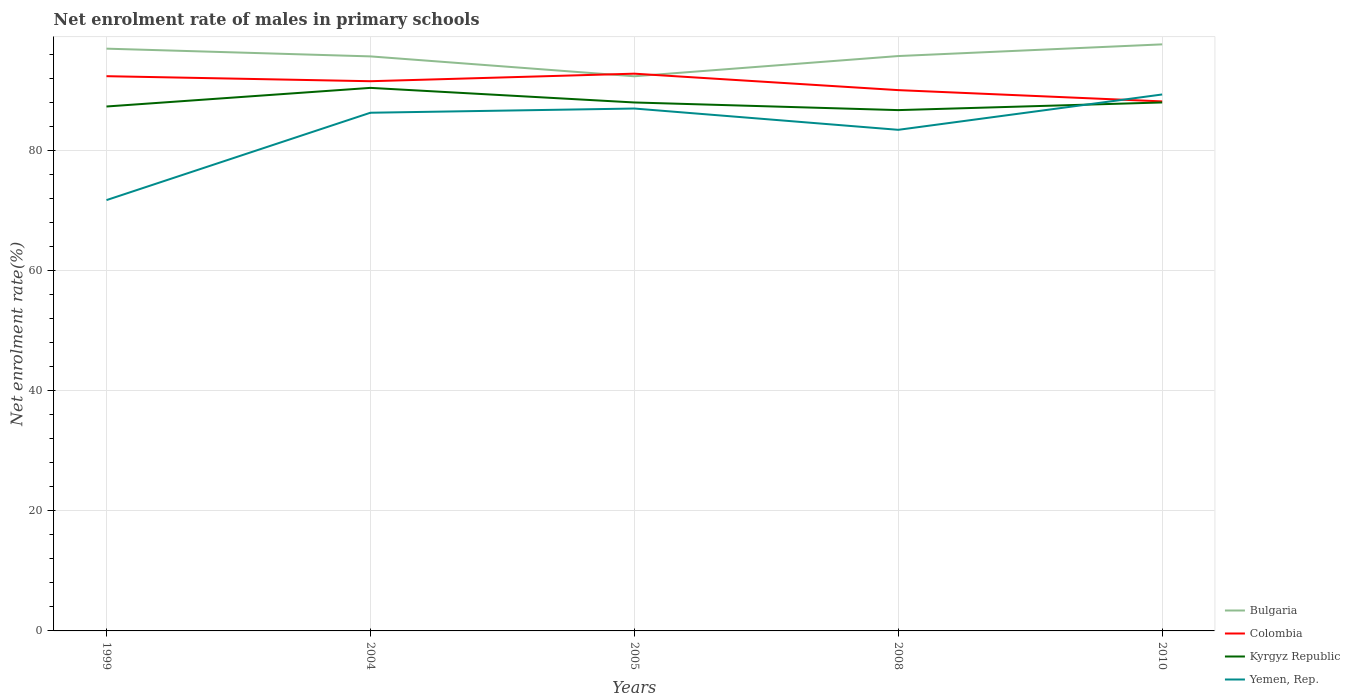How many different coloured lines are there?
Offer a terse response. 4. Across all years, what is the maximum net enrolment rate of males in primary schools in Yemen, Rep.?
Provide a succinct answer. 71.79. In which year was the net enrolment rate of males in primary schools in Colombia maximum?
Your answer should be very brief. 2010. What is the total net enrolment rate of males in primary schools in Yemen, Rep. in the graph?
Give a very brief answer. 2.85. What is the difference between the highest and the second highest net enrolment rate of males in primary schools in Colombia?
Ensure brevity in your answer.  4.62. What is the difference between the highest and the lowest net enrolment rate of males in primary schools in Yemen, Rep.?
Provide a succinct answer. 3. Is the net enrolment rate of males in primary schools in Bulgaria strictly greater than the net enrolment rate of males in primary schools in Yemen, Rep. over the years?
Keep it short and to the point. No. What is the difference between two consecutive major ticks on the Y-axis?
Offer a terse response. 20. Are the values on the major ticks of Y-axis written in scientific E-notation?
Your answer should be very brief. No. Does the graph contain any zero values?
Provide a succinct answer. No. Does the graph contain grids?
Give a very brief answer. Yes. Where does the legend appear in the graph?
Provide a succinct answer. Bottom right. How are the legend labels stacked?
Give a very brief answer. Vertical. What is the title of the graph?
Give a very brief answer. Net enrolment rate of males in primary schools. What is the label or title of the Y-axis?
Ensure brevity in your answer.  Net enrolment rate(%). What is the Net enrolment rate(%) in Bulgaria in 1999?
Offer a very short reply. 97.03. What is the Net enrolment rate(%) of Colombia in 1999?
Your answer should be compact. 92.44. What is the Net enrolment rate(%) of Kyrgyz Republic in 1999?
Keep it short and to the point. 87.39. What is the Net enrolment rate(%) of Yemen, Rep. in 1999?
Your answer should be compact. 71.79. What is the Net enrolment rate(%) of Bulgaria in 2004?
Make the answer very short. 95.74. What is the Net enrolment rate(%) of Colombia in 2004?
Make the answer very short. 91.61. What is the Net enrolment rate(%) in Kyrgyz Republic in 2004?
Your response must be concise. 90.5. What is the Net enrolment rate(%) in Yemen, Rep. in 2004?
Ensure brevity in your answer.  86.35. What is the Net enrolment rate(%) in Bulgaria in 2005?
Provide a short and direct response. 92.43. What is the Net enrolment rate(%) of Colombia in 2005?
Offer a very short reply. 92.86. What is the Net enrolment rate(%) of Kyrgyz Republic in 2005?
Ensure brevity in your answer.  88.06. What is the Net enrolment rate(%) of Yemen, Rep. in 2005?
Offer a very short reply. 87.05. What is the Net enrolment rate(%) of Bulgaria in 2008?
Your answer should be compact. 95.8. What is the Net enrolment rate(%) of Colombia in 2008?
Your answer should be very brief. 90.12. What is the Net enrolment rate(%) in Kyrgyz Republic in 2008?
Your answer should be compact. 86.79. What is the Net enrolment rate(%) in Yemen, Rep. in 2008?
Ensure brevity in your answer.  83.51. What is the Net enrolment rate(%) of Bulgaria in 2010?
Keep it short and to the point. 97.75. What is the Net enrolment rate(%) of Colombia in 2010?
Your answer should be compact. 88.24. What is the Net enrolment rate(%) of Kyrgyz Republic in 2010?
Ensure brevity in your answer.  88.07. What is the Net enrolment rate(%) of Yemen, Rep. in 2010?
Your answer should be compact. 89.39. Across all years, what is the maximum Net enrolment rate(%) in Bulgaria?
Your answer should be compact. 97.75. Across all years, what is the maximum Net enrolment rate(%) of Colombia?
Ensure brevity in your answer.  92.86. Across all years, what is the maximum Net enrolment rate(%) of Kyrgyz Republic?
Provide a succinct answer. 90.5. Across all years, what is the maximum Net enrolment rate(%) in Yemen, Rep.?
Ensure brevity in your answer.  89.39. Across all years, what is the minimum Net enrolment rate(%) in Bulgaria?
Give a very brief answer. 92.43. Across all years, what is the minimum Net enrolment rate(%) in Colombia?
Your answer should be very brief. 88.24. Across all years, what is the minimum Net enrolment rate(%) in Kyrgyz Republic?
Your answer should be compact. 86.79. Across all years, what is the minimum Net enrolment rate(%) in Yemen, Rep.?
Offer a very short reply. 71.79. What is the total Net enrolment rate(%) in Bulgaria in the graph?
Give a very brief answer. 478.75. What is the total Net enrolment rate(%) in Colombia in the graph?
Your answer should be compact. 455.27. What is the total Net enrolment rate(%) in Kyrgyz Republic in the graph?
Provide a short and direct response. 440.81. What is the total Net enrolment rate(%) of Yemen, Rep. in the graph?
Ensure brevity in your answer.  418.1. What is the difference between the Net enrolment rate(%) in Bulgaria in 1999 and that in 2004?
Provide a succinct answer. 1.29. What is the difference between the Net enrolment rate(%) in Colombia in 1999 and that in 2004?
Make the answer very short. 0.84. What is the difference between the Net enrolment rate(%) in Kyrgyz Republic in 1999 and that in 2004?
Offer a very short reply. -3.1. What is the difference between the Net enrolment rate(%) of Yemen, Rep. in 1999 and that in 2004?
Offer a terse response. -14.56. What is the difference between the Net enrolment rate(%) in Bulgaria in 1999 and that in 2005?
Your response must be concise. 4.6. What is the difference between the Net enrolment rate(%) in Colombia in 1999 and that in 2005?
Your response must be concise. -0.42. What is the difference between the Net enrolment rate(%) of Kyrgyz Republic in 1999 and that in 2005?
Provide a short and direct response. -0.67. What is the difference between the Net enrolment rate(%) in Yemen, Rep. in 1999 and that in 2005?
Your response must be concise. -15.26. What is the difference between the Net enrolment rate(%) in Bulgaria in 1999 and that in 2008?
Your answer should be very brief. 1.23. What is the difference between the Net enrolment rate(%) of Colombia in 1999 and that in 2008?
Offer a terse response. 2.32. What is the difference between the Net enrolment rate(%) of Kyrgyz Republic in 1999 and that in 2008?
Provide a short and direct response. 0.6. What is the difference between the Net enrolment rate(%) in Yemen, Rep. in 1999 and that in 2008?
Your answer should be compact. -11.71. What is the difference between the Net enrolment rate(%) in Bulgaria in 1999 and that in 2010?
Your response must be concise. -0.71. What is the difference between the Net enrolment rate(%) in Colombia in 1999 and that in 2010?
Your answer should be compact. 4.2. What is the difference between the Net enrolment rate(%) in Kyrgyz Republic in 1999 and that in 2010?
Give a very brief answer. -0.67. What is the difference between the Net enrolment rate(%) of Yemen, Rep. in 1999 and that in 2010?
Your answer should be compact. -17.6. What is the difference between the Net enrolment rate(%) of Bulgaria in 2004 and that in 2005?
Ensure brevity in your answer.  3.31. What is the difference between the Net enrolment rate(%) of Colombia in 2004 and that in 2005?
Your response must be concise. -1.26. What is the difference between the Net enrolment rate(%) of Kyrgyz Republic in 2004 and that in 2005?
Keep it short and to the point. 2.43. What is the difference between the Net enrolment rate(%) in Yemen, Rep. in 2004 and that in 2005?
Give a very brief answer. -0.7. What is the difference between the Net enrolment rate(%) in Bulgaria in 2004 and that in 2008?
Ensure brevity in your answer.  -0.06. What is the difference between the Net enrolment rate(%) in Colombia in 2004 and that in 2008?
Your answer should be compact. 1.49. What is the difference between the Net enrolment rate(%) of Kyrgyz Republic in 2004 and that in 2008?
Your answer should be very brief. 3.71. What is the difference between the Net enrolment rate(%) of Yemen, Rep. in 2004 and that in 2008?
Your response must be concise. 2.85. What is the difference between the Net enrolment rate(%) in Bulgaria in 2004 and that in 2010?
Keep it short and to the point. -2. What is the difference between the Net enrolment rate(%) of Colombia in 2004 and that in 2010?
Provide a succinct answer. 3.37. What is the difference between the Net enrolment rate(%) of Kyrgyz Republic in 2004 and that in 2010?
Your response must be concise. 2.43. What is the difference between the Net enrolment rate(%) of Yemen, Rep. in 2004 and that in 2010?
Give a very brief answer. -3.04. What is the difference between the Net enrolment rate(%) in Bulgaria in 2005 and that in 2008?
Your answer should be very brief. -3.37. What is the difference between the Net enrolment rate(%) in Colombia in 2005 and that in 2008?
Offer a terse response. 2.74. What is the difference between the Net enrolment rate(%) of Kyrgyz Republic in 2005 and that in 2008?
Provide a succinct answer. 1.27. What is the difference between the Net enrolment rate(%) of Yemen, Rep. in 2005 and that in 2008?
Keep it short and to the point. 3.55. What is the difference between the Net enrolment rate(%) in Bulgaria in 2005 and that in 2010?
Offer a very short reply. -5.32. What is the difference between the Net enrolment rate(%) of Colombia in 2005 and that in 2010?
Your answer should be compact. 4.62. What is the difference between the Net enrolment rate(%) in Kyrgyz Republic in 2005 and that in 2010?
Your answer should be very brief. -0. What is the difference between the Net enrolment rate(%) of Yemen, Rep. in 2005 and that in 2010?
Give a very brief answer. -2.34. What is the difference between the Net enrolment rate(%) of Bulgaria in 2008 and that in 2010?
Your answer should be compact. -1.95. What is the difference between the Net enrolment rate(%) in Colombia in 2008 and that in 2010?
Provide a short and direct response. 1.88. What is the difference between the Net enrolment rate(%) of Kyrgyz Republic in 2008 and that in 2010?
Your answer should be compact. -1.28. What is the difference between the Net enrolment rate(%) of Yemen, Rep. in 2008 and that in 2010?
Give a very brief answer. -5.89. What is the difference between the Net enrolment rate(%) in Bulgaria in 1999 and the Net enrolment rate(%) in Colombia in 2004?
Keep it short and to the point. 5.43. What is the difference between the Net enrolment rate(%) of Bulgaria in 1999 and the Net enrolment rate(%) of Kyrgyz Republic in 2004?
Keep it short and to the point. 6.54. What is the difference between the Net enrolment rate(%) in Bulgaria in 1999 and the Net enrolment rate(%) in Yemen, Rep. in 2004?
Offer a very short reply. 10.68. What is the difference between the Net enrolment rate(%) of Colombia in 1999 and the Net enrolment rate(%) of Kyrgyz Republic in 2004?
Make the answer very short. 1.95. What is the difference between the Net enrolment rate(%) in Colombia in 1999 and the Net enrolment rate(%) in Yemen, Rep. in 2004?
Ensure brevity in your answer.  6.09. What is the difference between the Net enrolment rate(%) in Kyrgyz Republic in 1999 and the Net enrolment rate(%) in Yemen, Rep. in 2004?
Ensure brevity in your answer.  1.04. What is the difference between the Net enrolment rate(%) in Bulgaria in 1999 and the Net enrolment rate(%) in Colombia in 2005?
Offer a very short reply. 4.17. What is the difference between the Net enrolment rate(%) of Bulgaria in 1999 and the Net enrolment rate(%) of Kyrgyz Republic in 2005?
Your response must be concise. 8.97. What is the difference between the Net enrolment rate(%) in Bulgaria in 1999 and the Net enrolment rate(%) in Yemen, Rep. in 2005?
Your answer should be very brief. 9.98. What is the difference between the Net enrolment rate(%) in Colombia in 1999 and the Net enrolment rate(%) in Kyrgyz Republic in 2005?
Give a very brief answer. 4.38. What is the difference between the Net enrolment rate(%) in Colombia in 1999 and the Net enrolment rate(%) in Yemen, Rep. in 2005?
Give a very brief answer. 5.39. What is the difference between the Net enrolment rate(%) of Kyrgyz Republic in 1999 and the Net enrolment rate(%) of Yemen, Rep. in 2005?
Offer a terse response. 0.34. What is the difference between the Net enrolment rate(%) in Bulgaria in 1999 and the Net enrolment rate(%) in Colombia in 2008?
Offer a very short reply. 6.91. What is the difference between the Net enrolment rate(%) of Bulgaria in 1999 and the Net enrolment rate(%) of Kyrgyz Republic in 2008?
Give a very brief answer. 10.24. What is the difference between the Net enrolment rate(%) in Bulgaria in 1999 and the Net enrolment rate(%) in Yemen, Rep. in 2008?
Offer a very short reply. 13.53. What is the difference between the Net enrolment rate(%) in Colombia in 1999 and the Net enrolment rate(%) in Kyrgyz Republic in 2008?
Provide a short and direct response. 5.65. What is the difference between the Net enrolment rate(%) of Colombia in 1999 and the Net enrolment rate(%) of Yemen, Rep. in 2008?
Your answer should be very brief. 8.94. What is the difference between the Net enrolment rate(%) of Kyrgyz Republic in 1999 and the Net enrolment rate(%) of Yemen, Rep. in 2008?
Provide a succinct answer. 3.89. What is the difference between the Net enrolment rate(%) of Bulgaria in 1999 and the Net enrolment rate(%) of Colombia in 2010?
Give a very brief answer. 8.79. What is the difference between the Net enrolment rate(%) of Bulgaria in 1999 and the Net enrolment rate(%) of Kyrgyz Republic in 2010?
Keep it short and to the point. 8.97. What is the difference between the Net enrolment rate(%) of Bulgaria in 1999 and the Net enrolment rate(%) of Yemen, Rep. in 2010?
Provide a short and direct response. 7.64. What is the difference between the Net enrolment rate(%) in Colombia in 1999 and the Net enrolment rate(%) in Kyrgyz Republic in 2010?
Offer a very short reply. 4.38. What is the difference between the Net enrolment rate(%) of Colombia in 1999 and the Net enrolment rate(%) of Yemen, Rep. in 2010?
Your answer should be compact. 3.05. What is the difference between the Net enrolment rate(%) in Kyrgyz Republic in 1999 and the Net enrolment rate(%) in Yemen, Rep. in 2010?
Your answer should be very brief. -2. What is the difference between the Net enrolment rate(%) of Bulgaria in 2004 and the Net enrolment rate(%) of Colombia in 2005?
Make the answer very short. 2.88. What is the difference between the Net enrolment rate(%) of Bulgaria in 2004 and the Net enrolment rate(%) of Kyrgyz Republic in 2005?
Offer a very short reply. 7.68. What is the difference between the Net enrolment rate(%) of Bulgaria in 2004 and the Net enrolment rate(%) of Yemen, Rep. in 2005?
Provide a succinct answer. 8.69. What is the difference between the Net enrolment rate(%) in Colombia in 2004 and the Net enrolment rate(%) in Kyrgyz Republic in 2005?
Provide a succinct answer. 3.54. What is the difference between the Net enrolment rate(%) of Colombia in 2004 and the Net enrolment rate(%) of Yemen, Rep. in 2005?
Provide a short and direct response. 4.55. What is the difference between the Net enrolment rate(%) of Kyrgyz Republic in 2004 and the Net enrolment rate(%) of Yemen, Rep. in 2005?
Give a very brief answer. 3.44. What is the difference between the Net enrolment rate(%) of Bulgaria in 2004 and the Net enrolment rate(%) of Colombia in 2008?
Your response must be concise. 5.62. What is the difference between the Net enrolment rate(%) of Bulgaria in 2004 and the Net enrolment rate(%) of Kyrgyz Republic in 2008?
Offer a terse response. 8.95. What is the difference between the Net enrolment rate(%) of Bulgaria in 2004 and the Net enrolment rate(%) of Yemen, Rep. in 2008?
Offer a terse response. 12.24. What is the difference between the Net enrolment rate(%) of Colombia in 2004 and the Net enrolment rate(%) of Kyrgyz Republic in 2008?
Provide a succinct answer. 4.82. What is the difference between the Net enrolment rate(%) in Colombia in 2004 and the Net enrolment rate(%) in Yemen, Rep. in 2008?
Your answer should be very brief. 8.1. What is the difference between the Net enrolment rate(%) of Kyrgyz Republic in 2004 and the Net enrolment rate(%) of Yemen, Rep. in 2008?
Give a very brief answer. 6.99. What is the difference between the Net enrolment rate(%) in Bulgaria in 2004 and the Net enrolment rate(%) in Colombia in 2010?
Give a very brief answer. 7.5. What is the difference between the Net enrolment rate(%) in Bulgaria in 2004 and the Net enrolment rate(%) in Kyrgyz Republic in 2010?
Ensure brevity in your answer.  7.68. What is the difference between the Net enrolment rate(%) in Bulgaria in 2004 and the Net enrolment rate(%) in Yemen, Rep. in 2010?
Provide a short and direct response. 6.35. What is the difference between the Net enrolment rate(%) in Colombia in 2004 and the Net enrolment rate(%) in Kyrgyz Republic in 2010?
Make the answer very short. 3.54. What is the difference between the Net enrolment rate(%) in Colombia in 2004 and the Net enrolment rate(%) in Yemen, Rep. in 2010?
Keep it short and to the point. 2.21. What is the difference between the Net enrolment rate(%) of Kyrgyz Republic in 2004 and the Net enrolment rate(%) of Yemen, Rep. in 2010?
Your response must be concise. 1.1. What is the difference between the Net enrolment rate(%) in Bulgaria in 2005 and the Net enrolment rate(%) in Colombia in 2008?
Offer a very short reply. 2.31. What is the difference between the Net enrolment rate(%) in Bulgaria in 2005 and the Net enrolment rate(%) in Kyrgyz Republic in 2008?
Ensure brevity in your answer.  5.64. What is the difference between the Net enrolment rate(%) in Bulgaria in 2005 and the Net enrolment rate(%) in Yemen, Rep. in 2008?
Make the answer very short. 8.92. What is the difference between the Net enrolment rate(%) of Colombia in 2005 and the Net enrolment rate(%) of Kyrgyz Republic in 2008?
Your response must be concise. 6.07. What is the difference between the Net enrolment rate(%) of Colombia in 2005 and the Net enrolment rate(%) of Yemen, Rep. in 2008?
Your answer should be very brief. 9.36. What is the difference between the Net enrolment rate(%) of Kyrgyz Republic in 2005 and the Net enrolment rate(%) of Yemen, Rep. in 2008?
Offer a very short reply. 4.56. What is the difference between the Net enrolment rate(%) in Bulgaria in 2005 and the Net enrolment rate(%) in Colombia in 2010?
Offer a very short reply. 4.19. What is the difference between the Net enrolment rate(%) of Bulgaria in 2005 and the Net enrolment rate(%) of Kyrgyz Republic in 2010?
Your answer should be compact. 4.36. What is the difference between the Net enrolment rate(%) of Bulgaria in 2005 and the Net enrolment rate(%) of Yemen, Rep. in 2010?
Ensure brevity in your answer.  3.03. What is the difference between the Net enrolment rate(%) of Colombia in 2005 and the Net enrolment rate(%) of Kyrgyz Republic in 2010?
Offer a very short reply. 4.8. What is the difference between the Net enrolment rate(%) of Colombia in 2005 and the Net enrolment rate(%) of Yemen, Rep. in 2010?
Ensure brevity in your answer.  3.47. What is the difference between the Net enrolment rate(%) of Kyrgyz Republic in 2005 and the Net enrolment rate(%) of Yemen, Rep. in 2010?
Your response must be concise. -1.33. What is the difference between the Net enrolment rate(%) of Bulgaria in 2008 and the Net enrolment rate(%) of Colombia in 2010?
Offer a very short reply. 7.56. What is the difference between the Net enrolment rate(%) of Bulgaria in 2008 and the Net enrolment rate(%) of Kyrgyz Republic in 2010?
Offer a very short reply. 7.73. What is the difference between the Net enrolment rate(%) in Bulgaria in 2008 and the Net enrolment rate(%) in Yemen, Rep. in 2010?
Provide a short and direct response. 6.4. What is the difference between the Net enrolment rate(%) of Colombia in 2008 and the Net enrolment rate(%) of Kyrgyz Republic in 2010?
Your response must be concise. 2.05. What is the difference between the Net enrolment rate(%) of Colombia in 2008 and the Net enrolment rate(%) of Yemen, Rep. in 2010?
Your answer should be compact. 0.73. What is the difference between the Net enrolment rate(%) of Kyrgyz Republic in 2008 and the Net enrolment rate(%) of Yemen, Rep. in 2010?
Offer a very short reply. -2.6. What is the average Net enrolment rate(%) of Bulgaria per year?
Offer a very short reply. 95.75. What is the average Net enrolment rate(%) in Colombia per year?
Offer a terse response. 91.05. What is the average Net enrolment rate(%) in Kyrgyz Republic per year?
Give a very brief answer. 88.16. What is the average Net enrolment rate(%) in Yemen, Rep. per year?
Provide a succinct answer. 83.62. In the year 1999, what is the difference between the Net enrolment rate(%) in Bulgaria and Net enrolment rate(%) in Colombia?
Offer a very short reply. 4.59. In the year 1999, what is the difference between the Net enrolment rate(%) in Bulgaria and Net enrolment rate(%) in Kyrgyz Republic?
Provide a succinct answer. 9.64. In the year 1999, what is the difference between the Net enrolment rate(%) in Bulgaria and Net enrolment rate(%) in Yemen, Rep.?
Provide a short and direct response. 25.24. In the year 1999, what is the difference between the Net enrolment rate(%) of Colombia and Net enrolment rate(%) of Kyrgyz Republic?
Your answer should be compact. 5.05. In the year 1999, what is the difference between the Net enrolment rate(%) in Colombia and Net enrolment rate(%) in Yemen, Rep.?
Your answer should be compact. 20.65. In the year 1999, what is the difference between the Net enrolment rate(%) of Kyrgyz Republic and Net enrolment rate(%) of Yemen, Rep.?
Provide a short and direct response. 15.6. In the year 2004, what is the difference between the Net enrolment rate(%) of Bulgaria and Net enrolment rate(%) of Colombia?
Provide a succinct answer. 4.14. In the year 2004, what is the difference between the Net enrolment rate(%) of Bulgaria and Net enrolment rate(%) of Kyrgyz Republic?
Your answer should be compact. 5.25. In the year 2004, what is the difference between the Net enrolment rate(%) in Bulgaria and Net enrolment rate(%) in Yemen, Rep.?
Your response must be concise. 9.39. In the year 2004, what is the difference between the Net enrolment rate(%) in Colombia and Net enrolment rate(%) in Kyrgyz Republic?
Provide a short and direct response. 1.11. In the year 2004, what is the difference between the Net enrolment rate(%) of Colombia and Net enrolment rate(%) of Yemen, Rep.?
Provide a succinct answer. 5.25. In the year 2004, what is the difference between the Net enrolment rate(%) of Kyrgyz Republic and Net enrolment rate(%) of Yemen, Rep.?
Provide a short and direct response. 4.14. In the year 2005, what is the difference between the Net enrolment rate(%) in Bulgaria and Net enrolment rate(%) in Colombia?
Your answer should be very brief. -0.43. In the year 2005, what is the difference between the Net enrolment rate(%) of Bulgaria and Net enrolment rate(%) of Kyrgyz Republic?
Offer a terse response. 4.37. In the year 2005, what is the difference between the Net enrolment rate(%) in Bulgaria and Net enrolment rate(%) in Yemen, Rep.?
Offer a terse response. 5.37. In the year 2005, what is the difference between the Net enrolment rate(%) in Colombia and Net enrolment rate(%) in Kyrgyz Republic?
Your answer should be compact. 4.8. In the year 2005, what is the difference between the Net enrolment rate(%) in Colombia and Net enrolment rate(%) in Yemen, Rep.?
Keep it short and to the point. 5.81. In the year 2005, what is the difference between the Net enrolment rate(%) in Kyrgyz Republic and Net enrolment rate(%) in Yemen, Rep.?
Offer a very short reply. 1.01. In the year 2008, what is the difference between the Net enrolment rate(%) in Bulgaria and Net enrolment rate(%) in Colombia?
Your answer should be compact. 5.68. In the year 2008, what is the difference between the Net enrolment rate(%) in Bulgaria and Net enrolment rate(%) in Kyrgyz Republic?
Provide a succinct answer. 9.01. In the year 2008, what is the difference between the Net enrolment rate(%) of Bulgaria and Net enrolment rate(%) of Yemen, Rep.?
Your response must be concise. 12.29. In the year 2008, what is the difference between the Net enrolment rate(%) in Colombia and Net enrolment rate(%) in Kyrgyz Republic?
Provide a succinct answer. 3.33. In the year 2008, what is the difference between the Net enrolment rate(%) of Colombia and Net enrolment rate(%) of Yemen, Rep.?
Provide a succinct answer. 6.61. In the year 2008, what is the difference between the Net enrolment rate(%) in Kyrgyz Republic and Net enrolment rate(%) in Yemen, Rep.?
Provide a succinct answer. 3.28. In the year 2010, what is the difference between the Net enrolment rate(%) in Bulgaria and Net enrolment rate(%) in Colombia?
Provide a succinct answer. 9.51. In the year 2010, what is the difference between the Net enrolment rate(%) of Bulgaria and Net enrolment rate(%) of Kyrgyz Republic?
Your answer should be compact. 9.68. In the year 2010, what is the difference between the Net enrolment rate(%) in Bulgaria and Net enrolment rate(%) in Yemen, Rep.?
Ensure brevity in your answer.  8.35. In the year 2010, what is the difference between the Net enrolment rate(%) in Colombia and Net enrolment rate(%) in Kyrgyz Republic?
Offer a very short reply. 0.17. In the year 2010, what is the difference between the Net enrolment rate(%) of Colombia and Net enrolment rate(%) of Yemen, Rep.?
Your answer should be compact. -1.15. In the year 2010, what is the difference between the Net enrolment rate(%) in Kyrgyz Republic and Net enrolment rate(%) in Yemen, Rep.?
Keep it short and to the point. -1.33. What is the ratio of the Net enrolment rate(%) of Bulgaria in 1999 to that in 2004?
Offer a terse response. 1.01. What is the ratio of the Net enrolment rate(%) in Colombia in 1999 to that in 2004?
Your answer should be very brief. 1.01. What is the ratio of the Net enrolment rate(%) in Kyrgyz Republic in 1999 to that in 2004?
Offer a terse response. 0.97. What is the ratio of the Net enrolment rate(%) of Yemen, Rep. in 1999 to that in 2004?
Offer a terse response. 0.83. What is the ratio of the Net enrolment rate(%) of Bulgaria in 1999 to that in 2005?
Ensure brevity in your answer.  1.05. What is the ratio of the Net enrolment rate(%) of Yemen, Rep. in 1999 to that in 2005?
Provide a short and direct response. 0.82. What is the ratio of the Net enrolment rate(%) in Bulgaria in 1999 to that in 2008?
Offer a terse response. 1.01. What is the ratio of the Net enrolment rate(%) of Colombia in 1999 to that in 2008?
Provide a succinct answer. 1.03. What is the ratio of the Net enrolment rate(%) in Yemen, Rep. in 1999 to that in 2008?
Offer a very short reply. 0.86. What is the ratio of the Net enrolment rate(%) in Bulgaria in 1999 to that in 2010?
Give a very brief answer. 0.99. What is the ratio of the Net enrolment rate(%) in Colombia in 1999 to that in 2010?
Provide a short and direct response. 1.05. What is the ratio of the Net enrolment rate(%) in Kyrgyz Republic in 1999 to that in 2010?
Your answer should be very brief. 0.99. What is the ratio of the Net enrolment rate(%) of Yemen, Rep. in 1999 to that in 2010?
Offer a terse response. 0.8. What is the ratio of the Net enrolment rate(%) of Bulgaria in 2004 to that in 2005?
Ensure brevity in your answer.  1.04. What is the ratio of the Net enrolment rate(%) in Colombia in 2004 to that in 2005?
Your answer should be very brief. 0.99. What is the ratio of the Net enrolment rate(%) of Kyrgyz Republic in 2004 to that in 2005?
Offer a terse response. 1.03. What is the ratio of the Net enrolment rate(%) of Yemen, Rep. in 2004 to that in 2005?
Your response must be concise. 0.99. What is the ratio of the Net enrolment rate(%) of Bulgaria in 2004 to that in 2008?
Offer a very short reply. 1. What is the ratio of the Net enrolment rate(%) of Colombia in 2004 to that in 2008?
Provide a succinct answer. 1.02. What is the ratio of the Net enrolment rate(%) of Kyrgyz Republic in 2004 to that in 2008?
Ensure brevity in your answer.  1.04. What is the ratio of the Net enrolment rate(%) in Yemen, Rep. in 2004 to that in 2008?
Provide a short and direct response. 1.03. What is the ratio of the Net enrolment rate(%) in Bulgaria in 2004 to that in 2010?
Your response must be concise. 0.98. What is the ratio of the Net enrolment rate(%) in Colombia in 2004 to that in 2010?
Your response must be concise. 1.04. What is the ratio of the Net enrolment rate(%) in Kyrgyz Republic in 2004 to that in 2010?
Your response must be concise. 1.03. What is the ratio of the Net enrolment rate(%) in Yemen, Rep. in 2004 to that in 2010?
Keep it short and to the point. 0.97. What is the ratio of the Net enrolment rate(%) in Bulgaria in 2005 to that in 2008?
Your answer should be very brief. 0.96. What is the ratio of the Net enrolment rate(%) in Colombia in 2005 to that in 2008?
Offer a very short reply. 1.03. What is the ratio of the Net enrolment rate(%) of Kyrgyz Republic in 2005 to that in 2008?
Provide a short and direct response. 1.01. What is the ratio of the Net enrolment rate(%) of Yemen, Rep. in 2005 to that in 2008?
Ensure brevity in your answer.  1.04. What is the ratio of the Net enrolment rate(%) of Bulgaria in 2005 to that in 2010?
Keep it short and to the point. 0.95. What is the ratio of the Net enrolment rate(%) in Colombia in 2005 to that in 2010?
Give a very brief answer. 1.05. What is the ratio of the Net enrolment rate(%) of Kyrgyz Republic in 2005 to that in 2010?
Your response must be concise. 1. What is the ratio of the Net enrolment rate(%) in Yemen, Rep. in 2005 to that in 2010?
Your answer should be very brief. 0.97. What is the ratio of the Net enrolment rate(%) of Bulgaria in 2008 to that in 2010?
Provide a succinct answer. 0.98. What is the ratio of the Net enrolment rate(%) in Colombia in 2008 to that in 2010?
Keep it short and to the point. 1.02. What is the ratio of the Net enrolment rate(%) of Kyrgyz Republic in 2008 to that in 2010?
Your answer should be compact. 0.99. What is the ratio of the Net enrolment rate(%) in Yemen, Rep. in 2008 to that in 2010?
Keep it short and to the point. 0.93. What is the difference between the highest and the second highest Net enrolment rate(%) of Bulgaria?
Offer a terse response. 0.71. What is the difference between the highest and the second highest Net enrolment rate(%) of Colombia?
Your answer should be compact. 0.42. What is the difference between the highest and the second highest Net enrolment rate(%) of Kyrgyz Republic?
Keep it short and to the point. 2.43. What is the difference between the highest and the second highest Net enrolment rate(%) of Yemen, Rep.?
Ensure brevity in your answer.  2.34. What is the difference between the highest and the lowest Net enrolment rate(%) of Bulgaria?
Offer a very short reply. 5.32. What is the difference between the highest and the lowest Net enrolment rate(%) in Colombia?
Your answer should be very brief. 4.62. What is the difference between the highest and the lowest Net enrolment rate(%) in Kyrgyz Republic?
Offer a very short reply. 3.71. What is the difference between the highest and the lowest Net enrolment rate(%) of Yemen, Rep.?
Provide a succinct answer. 17.6. 